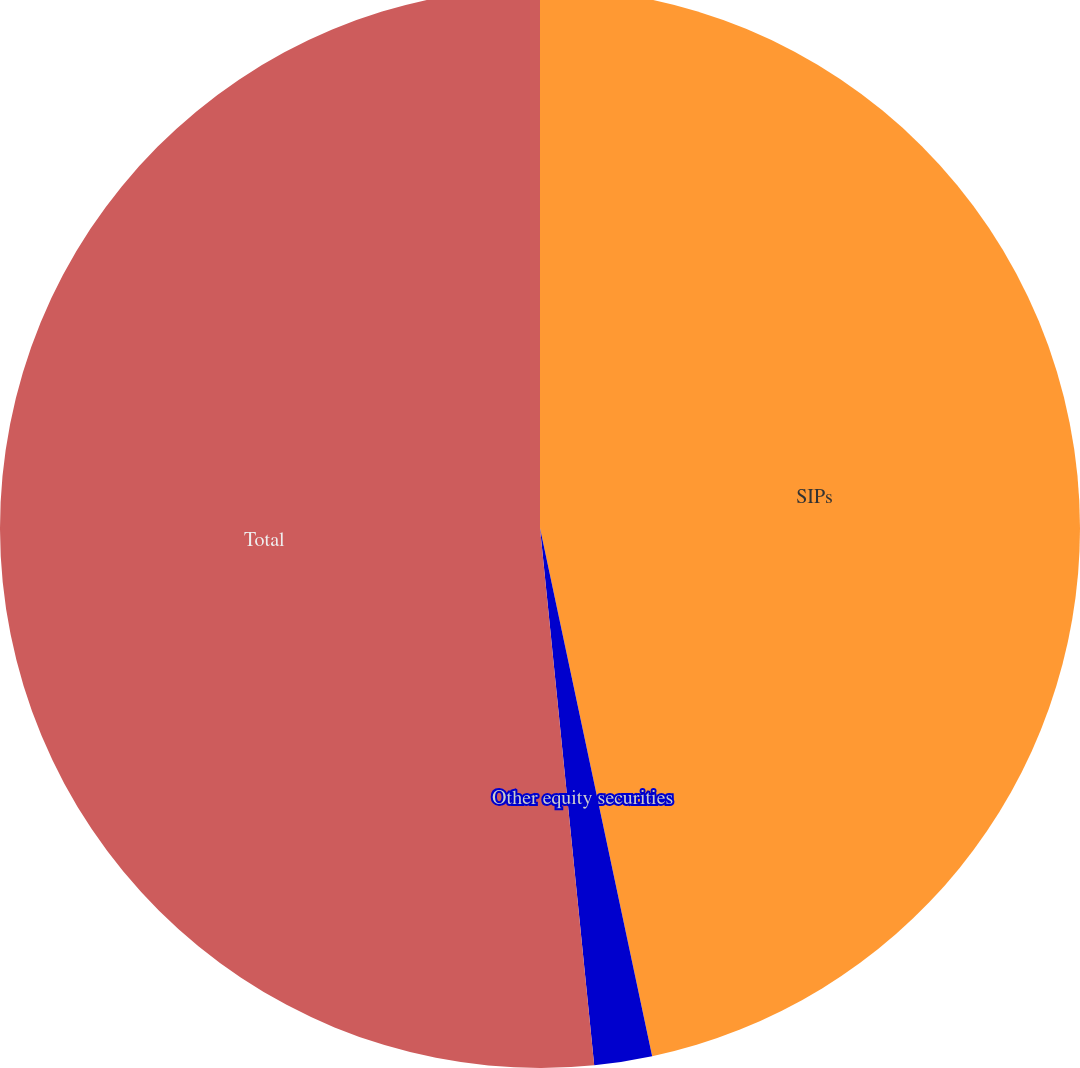Convert chart to OTSL. <chart><loc_0><loc_0><loc_500><loc_500><pie_chart><fcel>SIPs<fcel>Other equity securities<fcel>Total<nl><fcel>46.67%<fcel>1.73%<fcel>51.6%<nl></chart> 